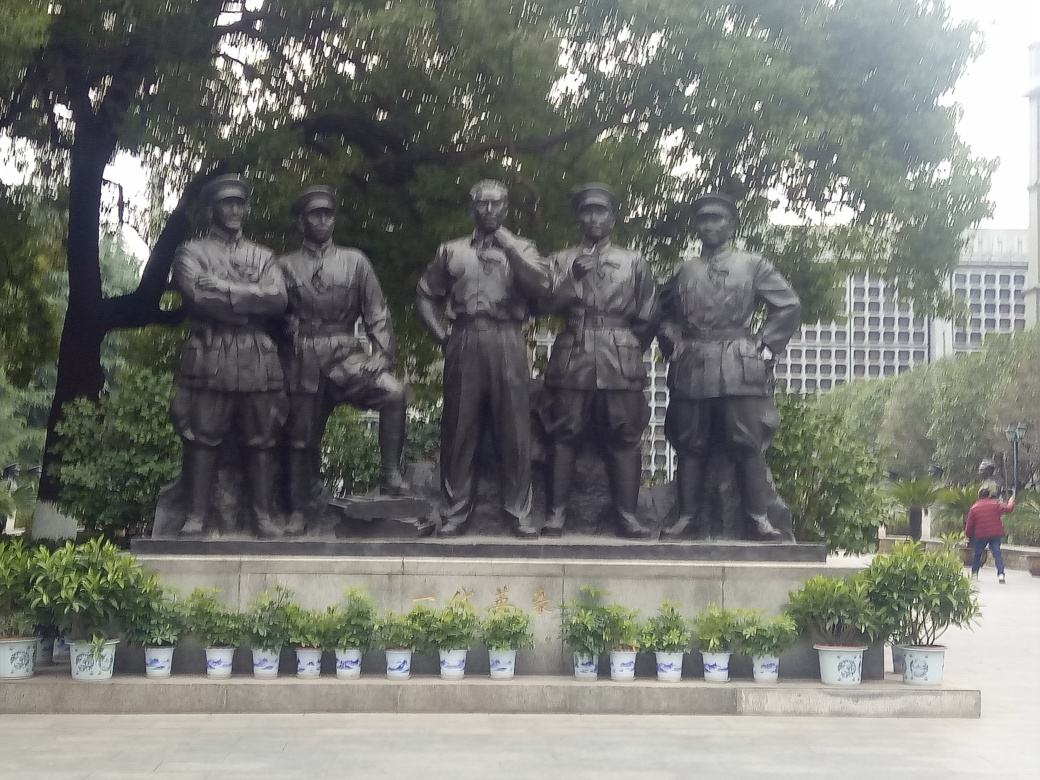What is depicted in this statue? The statue depicts a group of five figures, likely military personnel given their uniforms, standing side by side in a formal and commemorative pose. Does the statue convey any historical context? Yes, statues like this are often erected to honor significant historical events or individuals, typically representing a moment of unity, leadership, or collective effort in a military context. 